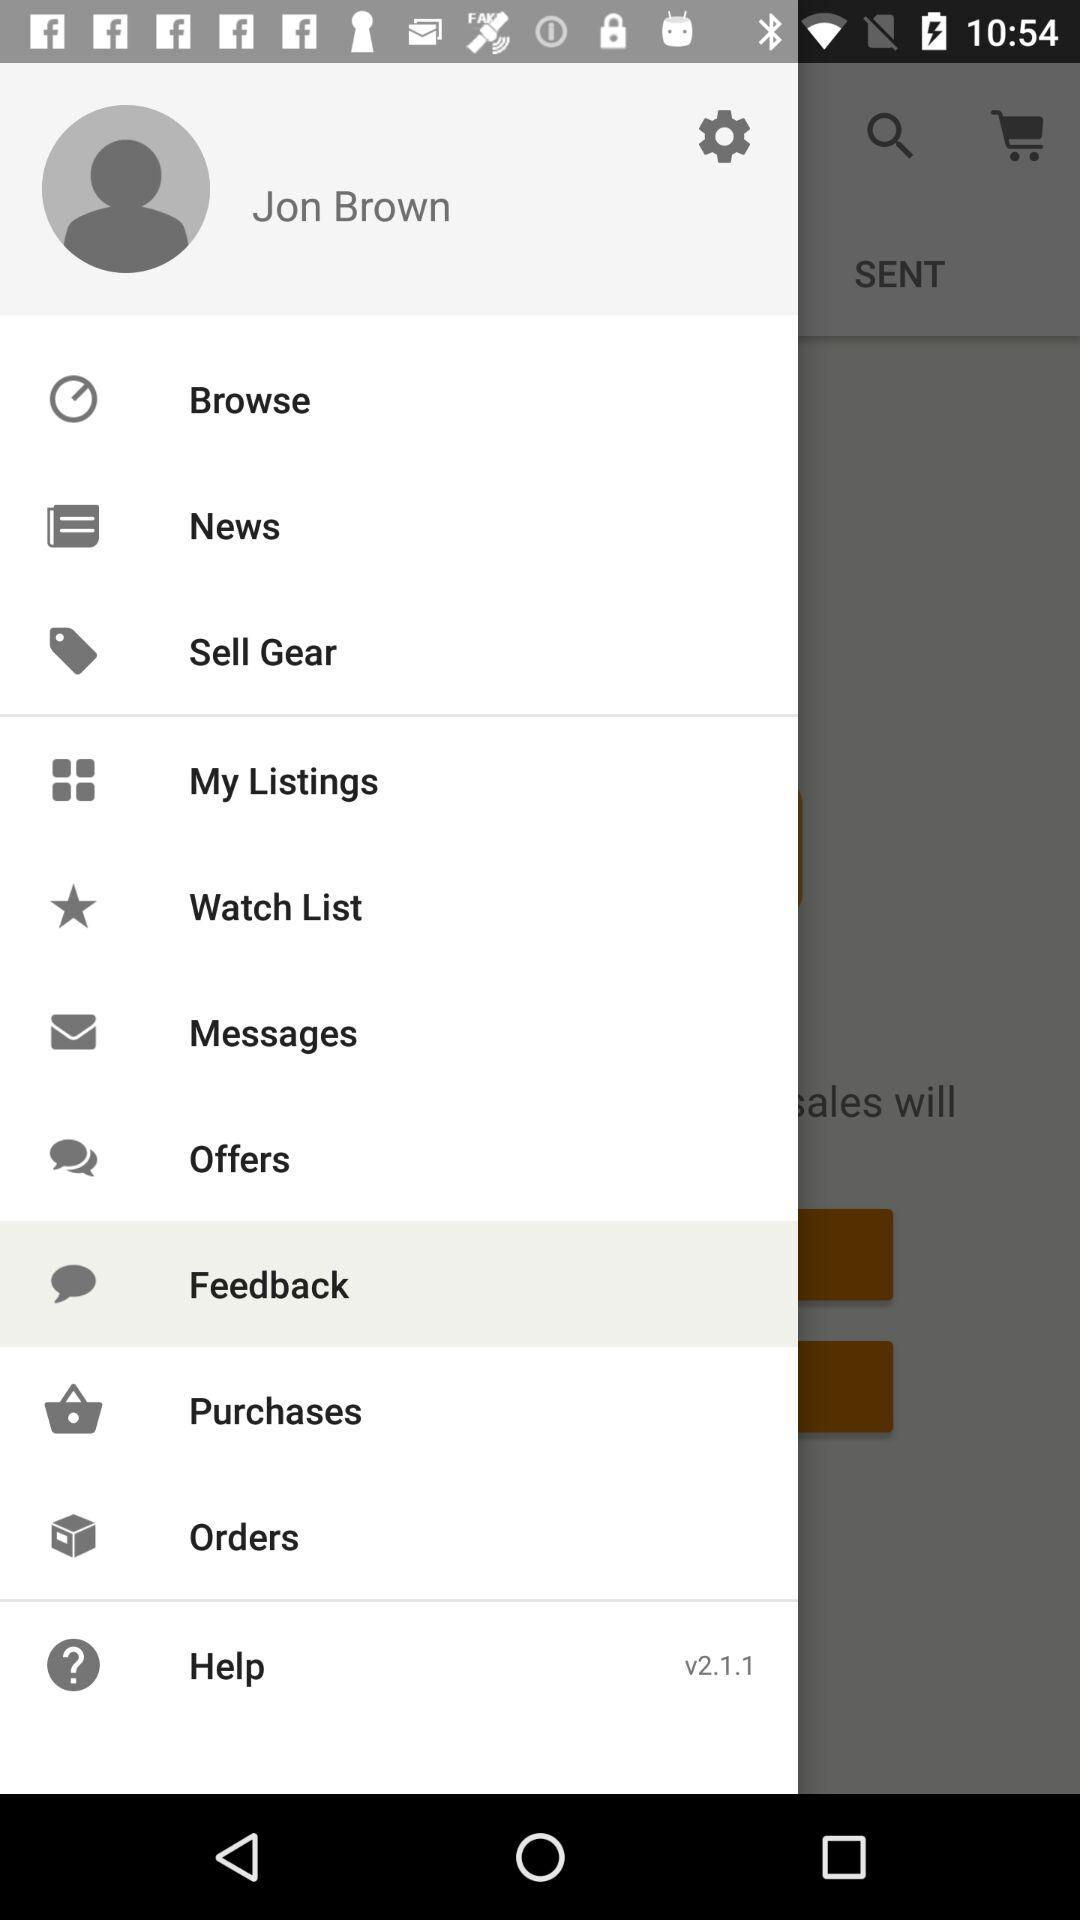What is the version? The version is v2.1.1. 